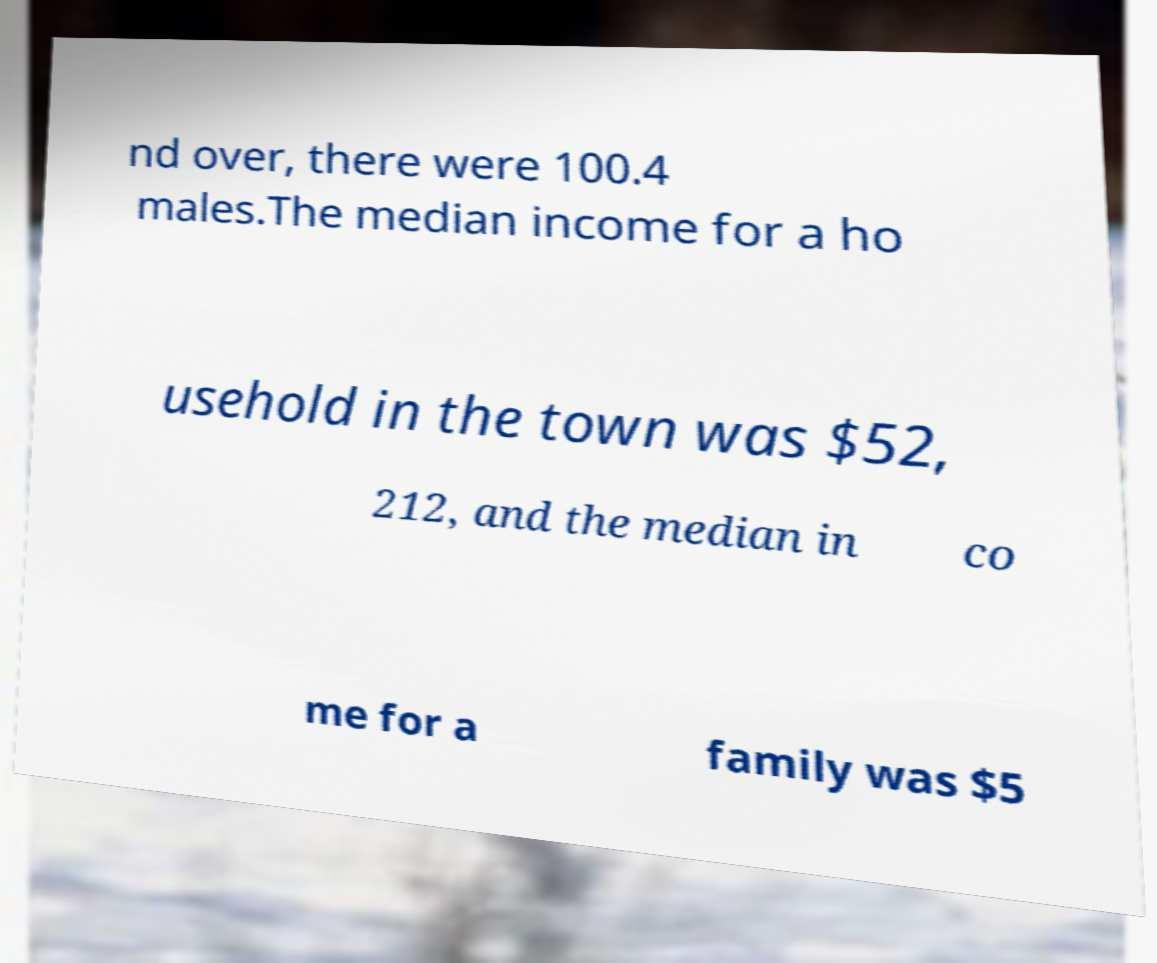Please read and relay the text visible in this image. What does it say? nd over, there were 100.4 males.The median income for a ho usehold in the town was $52, 212, and the median in co me for a family was $5 